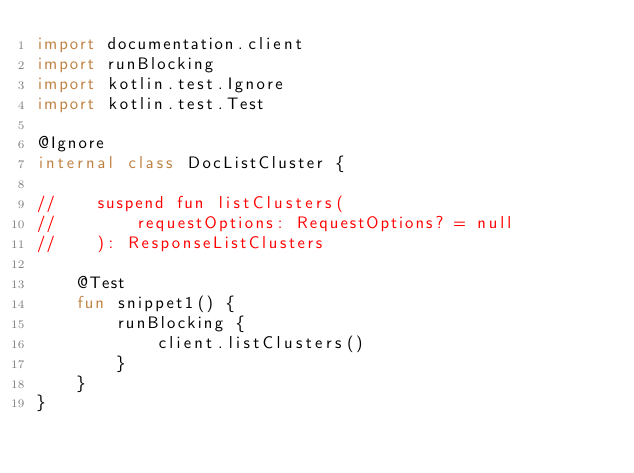Convert code to text. <code><loc_0><loc_0><loc_500><loc_500><_Kotlin_>import documentation.client
import runBlocking
import kotlin.test.Ignore
import kotlin.test.Test

@Ignore
internal class DocListCluster {

//    suspend fun listClusters(
//        requestOptions: RequestOptions? = null
//    ): ResponseListClusters

    @Test
    fun snippet1() {
        runBlocking {
            client.listClusters()
        }
    }
}
</code> 